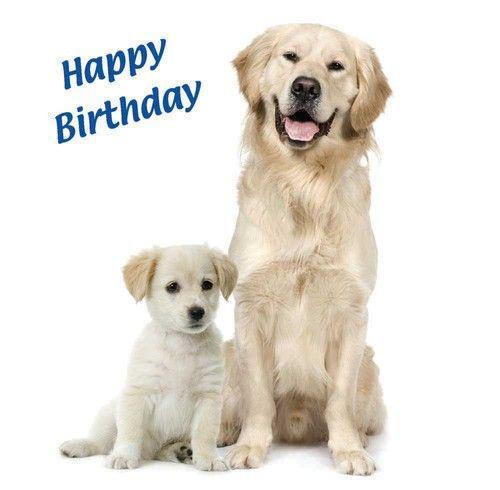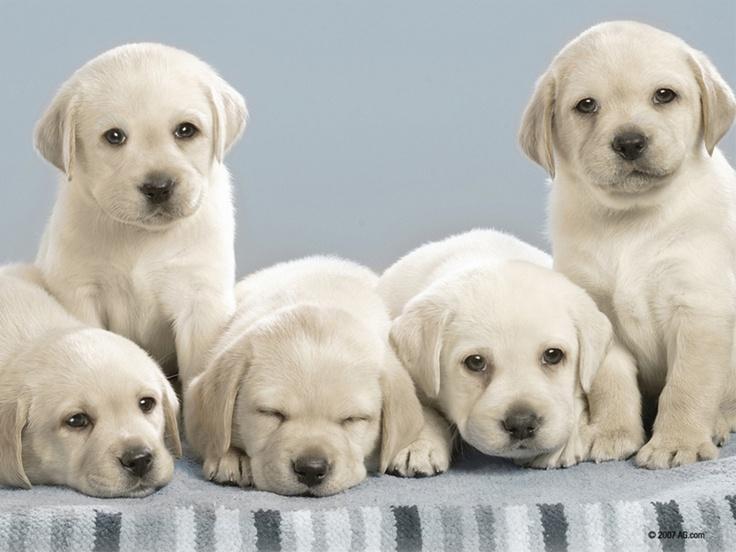The first image is the image on the left, the second image is the image on the right. For the images displayed, is the sentence "One image shows a group of five sitting and reclining puppies in an indoor setting." factually correct? Answer yes or no. Yes. The first image is the image on the left, the second image is the image on the right. Assess this claim about the two images: "Exactly seven dogs are shown, in groups of two and five.". Correct or not? Answer yes or no. Yes. 